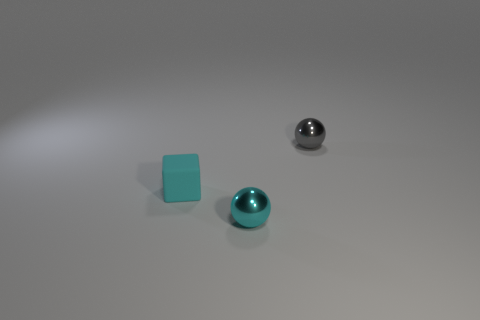Add 2 small cyan rubber cubes. How many objects exist? 5 Subtract all cubes. How many objects are left? 2 Add 1 tiny gray balls. How many tiny gray balls are left? 2 Add 3 small gray objects. How many small gray objects exist? 4 Subtract 0 green spheres. How many objects are left? 3 Subtract all tiny metal things. Subtract all gray things. How many objects are left? 0 